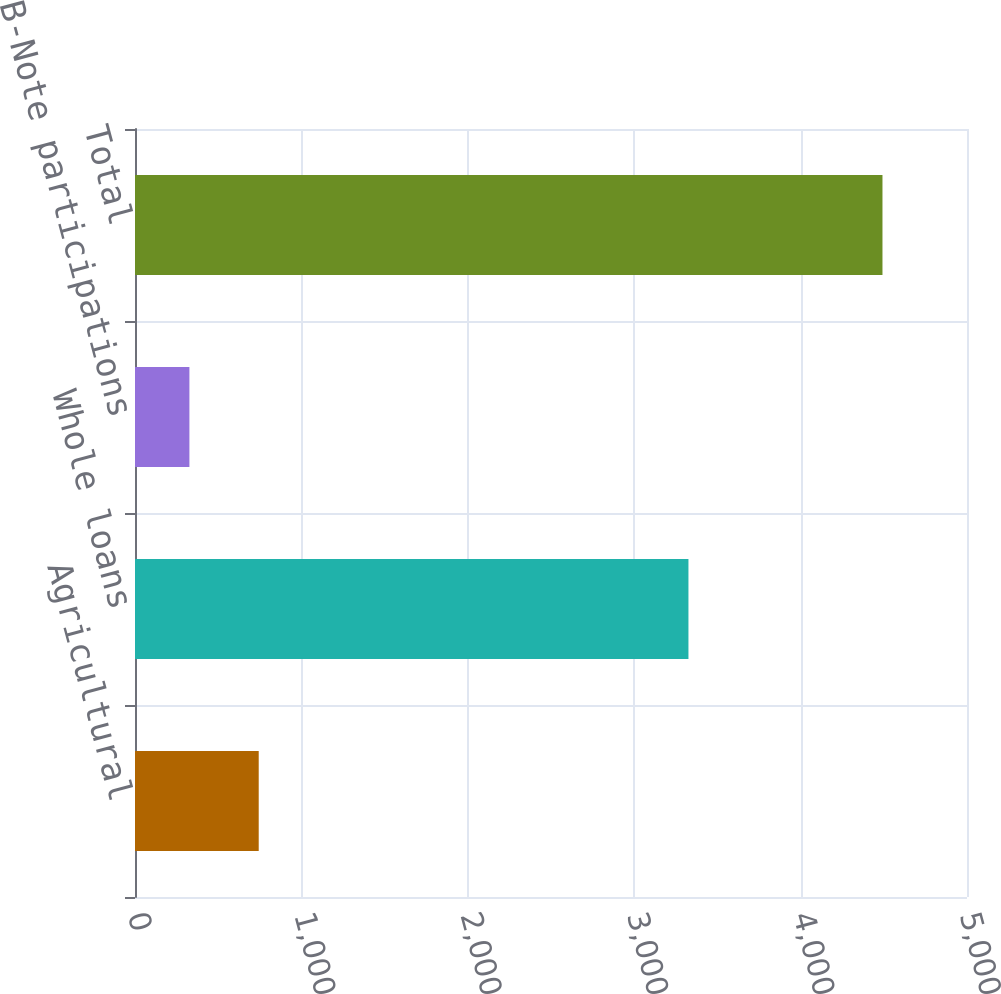Convert chart to OTSL. <chart><loc_0><loc_0><loc_500><loc_500><bar_chart><fcel>Agricultural<fcel>Whole loans<fcel>B-Note participations<fcel>Total<nl><fcel>743.5<fcel>3326<fcel>327<fcel>4492<nl></chart> 